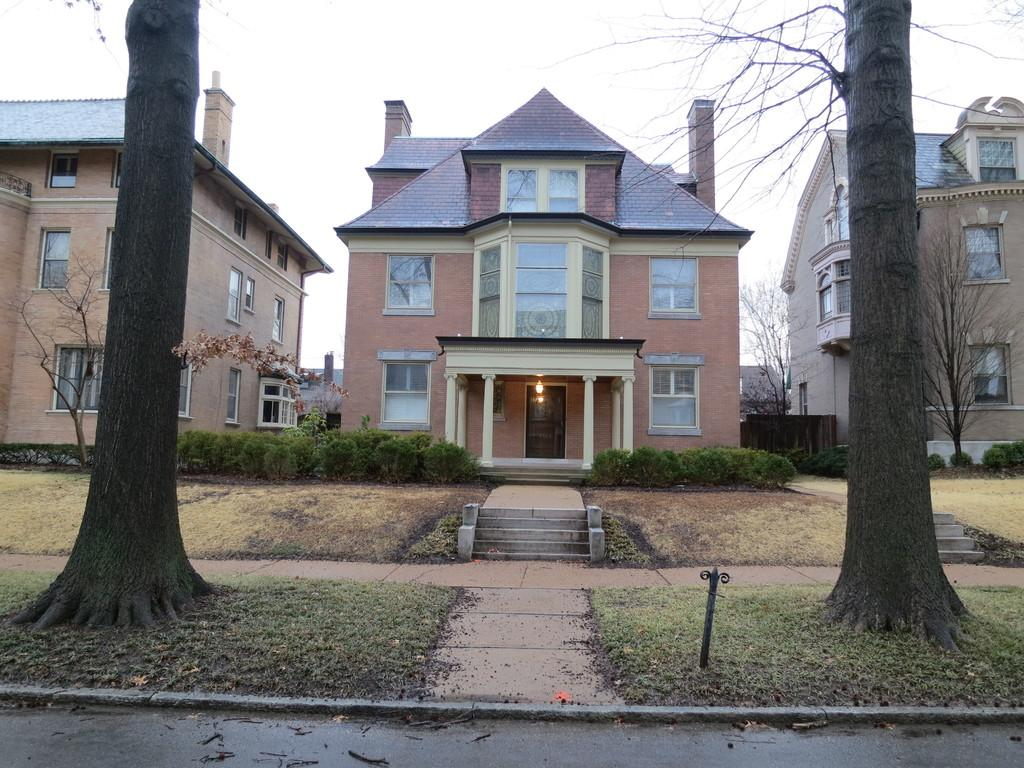What type of structure is present in the image? There is a building in the image. What colors are used for the building? The building is in brown and cream color. What other natural elements can be seen in the image? There are trees in the image. What color are the trees? The trees are in green color. What part of the natural environment is visible in the image? The sky is visible in the image. What color is the sky? The sky is in white color. What type of lumber is being used to construct the building in the image? There is no information about the type of lumber used in the construction of the building in the image. Can you see an arch in the building's design in the image? There is no mention of an arch in the building's design in the image. 